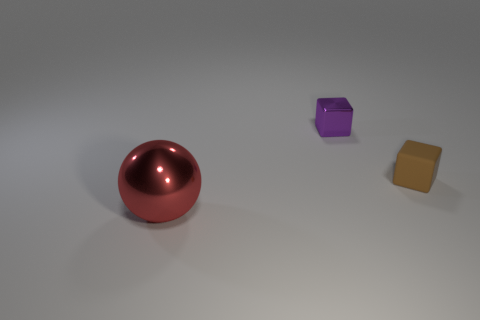Add 2 tiny yellow blocks. How many objects exist? 5 Subtract all balls. How many objects are left? 2 Subtract 1 balls. How many balls are left? 0 Subtract all cyan cubes. How many gray balls are left? 0 Subtract all gray cubes. Subtract all small things. How many objects are left? 1 Add 3 brown matte cubes. How many brown matte cubes are left? 4 Add 1 small gray rubber cylinders. How many small gray rubber cylinders exist? 1 Subtract 0 green cylinders. How many objects are left? 3 Subtract all gray cubes. Subtract all green cylinders. How many cubes are left? 2 